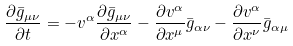<formula> <loc_0><loc_0><loc_500><loc_500>\frac { \partial \bar { g } _ { \mu \nu } } { \partial t } = - v ^ { \alpha } \frac { \partial \bar { g } _ { \mu \nu } } { \partial x ^ { \alpha } } - \frac { \partial v ^ { \alpha } } { \partial x ^ { \mu } } \bar { g } _ { \alpha \nu } - \frac { \partial v ^ { \alpha } } { \partial x ^ { \nu } } \bar { g } _ { \alpha \mu }</formula> 